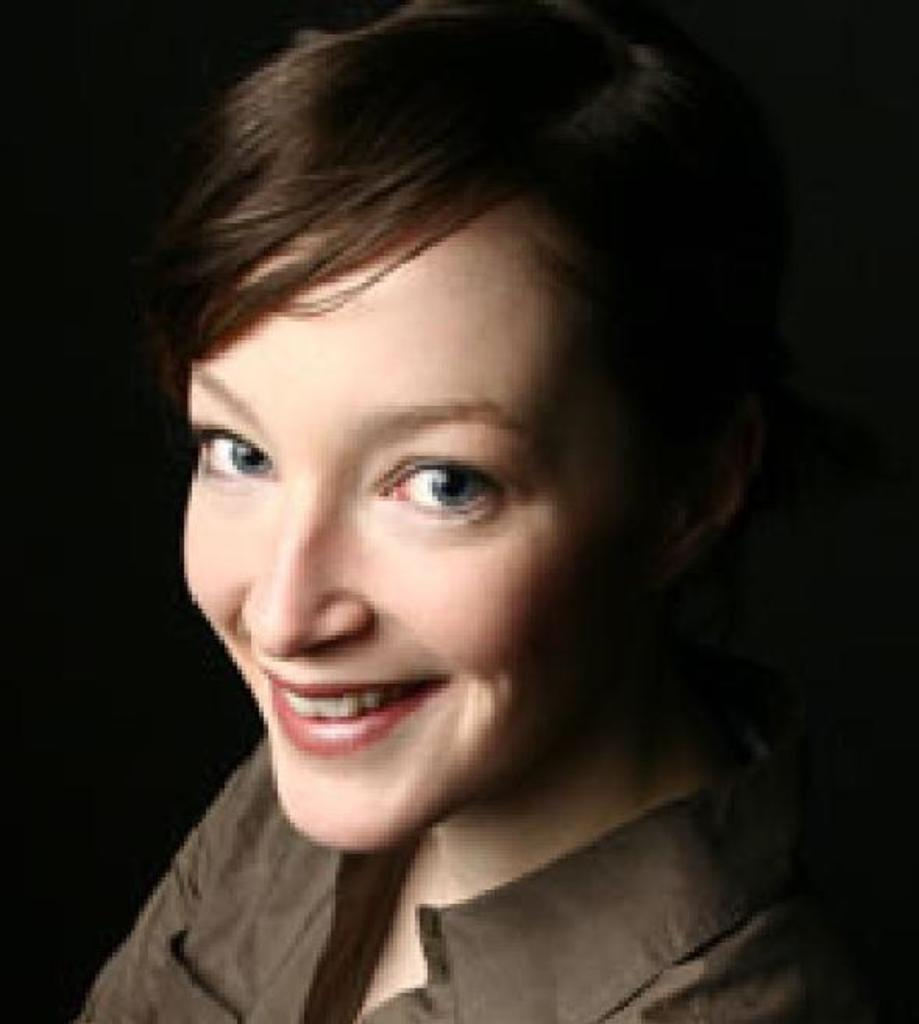Who is present in the image? There is a woman in the image. What is the woman wearing? The woman is wearing a shirt. What expression does the woman have? The woman is smiling. What can be observed about the background of the image? The background of the image is dark in color. What type of quiver can be seen on the woman's back in the image? There is no quiver present on the woman's back in the image. What acoustics can be heard in the background of the image? There is no sound or acoustics mentioned in the image, as it is a still photograph. 